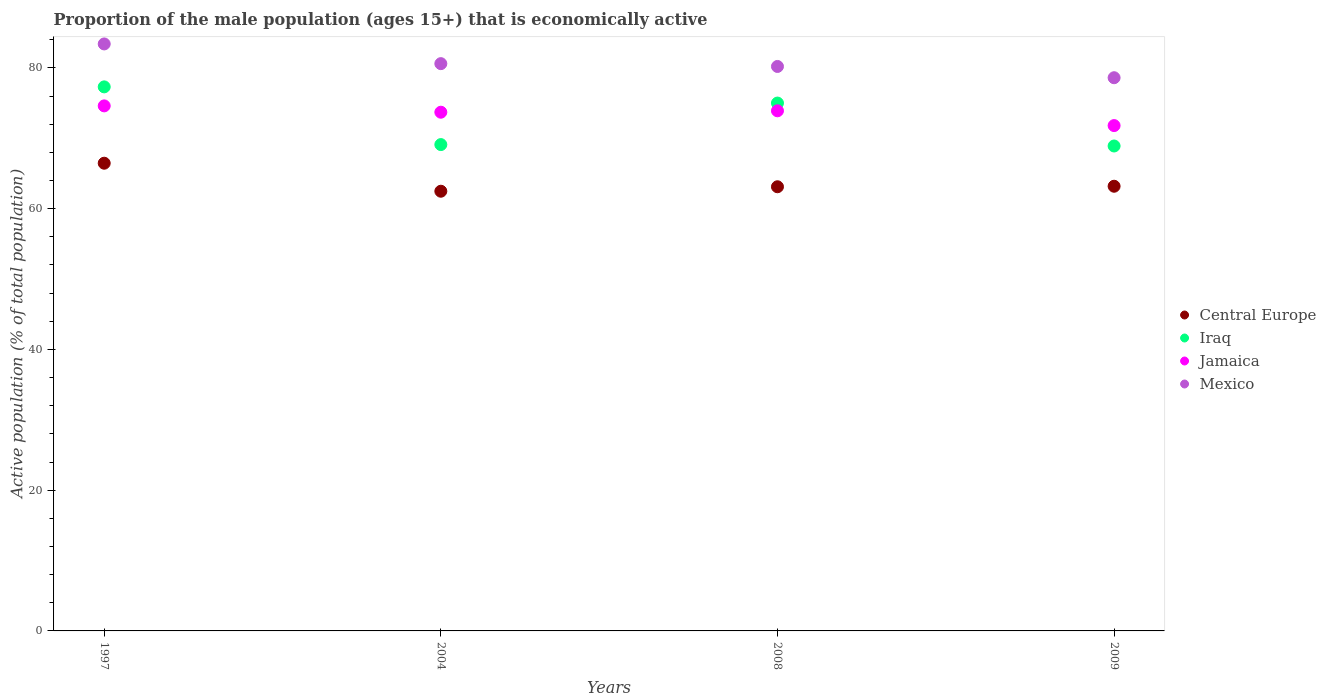What is the proportion of the male population that is economically active in Mexico in 2008?
Your answer should be very brief. 80.2. Across all years, what is the maximum proportion of the male population that is economically active in Central Europe?
Your response must be concise. 66.45. Across all years, what is the minimum proportion of the male population that is economically active in Jamaica?
Keep it short and to the point. 71.8. In which year was the proportion of the male population that is economically active in Mexico maximum?
Your answer should be compact. 1997. In which year was the proportion of the male population that is economically active in Jamaica minimum?
Offer a terse response. 2009. What is the total proportion of the male population that is economically active in Mexico in the graph?
Provide a succinct answer. 322.8. What is the difference between the proportion of the male population that is economically active in Central Europe in 1997 and that in 2008?
Give a very brief answer. 3.35. What is the difference between the proportion of the male population that is economically active in Jamaica in 2009 and the proportion of the male population that is economically active in Central Europe in 2008?
Provide a succinct answer. 8.69. What is the average proportion of the male population that is economically active in Central Europe per year?
Provide a short and direct response. 63.8. In how many years, is the proportion of the male population that is economically active in Central Europe greater than 44 %?
Provide a short and direct response. 4. What is the ratio of the proportion of the male population that is economically active in Mexico in 1997 to that in 2008?
Ensure brevity in your answer.  1.04. Is the proportion of the male population that is economically active in Mexico in 1997 less than that in 2004?
Make the answer very short. No. What is the difference between the highest and the second highest proportion of the male population that is economically active in Jamaica?
Provide a succinct answer. 0.7. What is the difference between the highest and the lowest proportion of the male population that is economically active in Iraq?
Provide a succinct answer. 8.4. In how many years, is the proportion of the male population that is economically active in Central Europe greater than the average proportion of the male population that is economically active in Central Europe taken over all years?
Ensure brevity in your answer.  1. Is the sum of the proportion of the male population that is economically active in Mexico in 1997 and 2004 greater than the maximum proportion of the male population that is economically active in Jamaica across all years?
Keep it short and to the point. Yes. Is it the case that in every year, the sum of the proportion of the male population that is economically active in Jamaica and proportion of the male population that is economically active in Mexico  is greater than the sum of proportion of the male population that is economically active in Iraq and proportion of the male population that is economically active in Central Europe?
Give a very brief answer. No. Is it the case that in every year, the sum of the proportion of the male population that is economically active in Jamaica and proportion of the male population that is economically active in Iraq  is greater than the proportion of the male population that is economically active in Central Europe?
Give a very brief answer. Yes. Does the proportion of the male population that is economically active in Central Europe monotonically increase over the years?
Your answer should be compact. No. Is the proportion of the male population that is economically active in Central Europe strictly greater than the proportion of the male population that is economically active in Iraq over the years?
Your answer should be very brief. No. Is the proportion of the male population that is economically active in Mexico strictly less than the proportion of the male population that is economically active in Central Europe over the years?
Offer a terse response. No. What is the difference between two consecutive major ticks on the Y-axis?
Offer a terse response. 20. Does the graph contain grids?
Offer a very short reply. No. What is the title of the graph?
Ensure brevity in your answer.  Proportion of the male population (ages 15+) that is economically active. What is the label or title of the X-axis?
Make the answer very short. Years. What is the label or title of the Y-axis?
Keep it short and to the point. Active population (% of total population). What is the Active population (% of total population) in Central Europe in 1997?
Ensure brevity in your answer.  66.45. What is the Active population (% of total population) in Iraq in 1997?
Give a very brief answer. 77.3. What is the Active population (% of total population) of Jamaica in 1997?
Offer a very short reply. 74.6. What is the Active population (% of total population) of Mexico in 1997?
Give a very brief answer. 83.4. What is the Active population (% of total population) of Central Europe in 2004?
Offer a terse response. 62.47. What is the Active population (% of total population) of Iraq in 2004?
Your response must be concise. 69.1. What is the Active population (% of total population) in Jamaica in 2004?
Offer a very short reply. 73.7. What is the Active population (% of total population) of Mexico in 2004?
Keep it short and to the point. 80.6. What is the Active population (% of total population) in Central Europe in 2008?
Your response must be concise. 63.11. What is the Active population (% of total population) of Jamaica in 2008?
Ensure brevity in your answer.  73.9. What is the Active population (% of total population) of Mexico in 2008?
Give a very brief answer. 80.2. What is the Active population (% of total population) of Central Europe in 2009?
Offer a terse response. 63.18. What is the Active population (% of total population) of Iraq in 2009?
Your answer should be very brief. 68.9. What is the Active population (% of total population) of Jamaica in 2009?
Your answer should be very brief. 71.8. What is the Active population (% of total population) in Mexico in 2009?
Your answer should be very brief. 78.6. Across all years, what is the maximum Active population (% of total population) in Central Europe?
Ensure brevity in your answer.  66.45. Across all years, what is the maximum Active population (% of total population) of Iraq?
Your response must be concise. 77.3. Across all years, what is the maximum Active population (% of total population) in Jamaica?
Provide a succinct answer. 74.6. Across all years, what is the maximum Active population (% of total population) in Mexico?
Keep it short and to the point. 83.4. Across all years, what is the minimum Active population (% of total population) of Central Europe?
Your response must be concise. 62.47. Across all years, what is the minimum Active population (% of total population) of Iraq?
Ensure brevity in your answer.  68.9. Across all years, what is the minimum Active population (% of total population) in Jamaica?
Offer a terse response. 71.8. Across all years, what is the minimum Active population (% of total population) of Mexico?
Provide a short and direct response. 78.6. What is the total Active population (% of total population) in Central Europe in the graph?
Your answer should be compact. 255.21. What is the total Active population (% of total population) of Iraq in the graph?
Provide a succinct answer. 290.3. What is the total Active population (% of total population) in Jamaica in the graph?
Ensure brevity in your answer.  294. What is the total Active population (% of total population) of Mexico in the graph?
Offer a very short reply. 322.8. What is the difference between the Active population (% of total population) of Central Europe in 1997 and that in 2004?
Provide a succinct answer. 3.98. What is the difference between the Active population (% of total population) of Iraq in 1997 and that in 2004?
Offer a terse response. 8.2. What is the difference between the Active population (% of total population) in Mexico in 1997 and that in 2004?
Provide a short and direct response. 2.8. What is the difference between the Active population (% of total population) of Central Europe in 1997 and that in 2008?
Provide a succinct answer. 3.35. What is the difference between the Active population (% of total population) of Central Europe in 1997 and that in 2009?
Ensure brevity in your answer.  3.27. What is the difference between the Active population (% of total population) of Iraq in 1997 and that in 2009?
Give a very brief answer. 8.4. What is the difference between the Active population (% of total population) in Jamaica in 1997 and that in 2009?
Offer a very short reply. 2.8. What is the difference between the Active population (% of total population) of Mexico in 1997 and that in 2009?
Your response must be concise. 4.8. What is the difference between the Active population (% of total population) of Central Europe in 2004 and that in 2008?
Make the answer very short. -0.64. What is the difference between the Active population (% of total population) of Iraq in 2004 and that in 2008?
Your answer should be compact. -5.9. What is the difference between the Active population (% of total population) of Jamaica in 2004 and that in 2008?
Offer a very short reply. -0.2. What is the difference between the Active population (% of total population) of Mexico in 2004 and that in 2008?
Ensure brevity in your answer.  0.4. What is the difference between the Active population (% of total population) of Central Europe in 2004 and that in 2009?
Ensure brevity in your answer.  -0.71. What is the difference between the Active population (% of total population) in Iraq in 2004 and that in 2009?
Your answer should be compact. 0.2. What is the difference between the Active population (% of total population) in Mexico in 2004 and that in 2009?
Offer a very short reply. 2. What is the difference between the Active population (% of total population) in Central Europe in 2008 and that in 2009?
Your answer should be very brief. -0.07. What is the difference between the Active population (% of total population) in Iraq in 2008 and that in 2009?
Give a very brief answer. 6.1. What is the difference between the Active population (% of total population) in Jamaica in 2008 and that in 2009?
Keep it short and to the point. 2.1. What is the difference between the Active population (% of total population) in Mexico in 2008 and that in 2009?
Make the answer very short. 1.6. What is the difference between the Active population (% of total population) of Central Europe in 1997 and the Active population (% of total population) of Iraq in 2004?
Give a very brief answer. -2.65. What is the difference between the Active population (% of total population) of Central Europe in 1997 and the Active population (% of total population) of Jamaica in 2004?
Your response must be concise. -7.25. What is the difference between the Active population (% of total population) in Central Europe in 1997 and the Active population (% of total population) in Mexico in 2004?
Provide a succinct answer. -14.15. What is the difference between the Active population (% of total population) in Iraq in 1997 and the Active population (% of total population) in Jamaica in 2004?
Provide a succinct answer. 3.6. What is the difference between the Active population (% of total population) of Iraq in 1997 and the Active population (% of total population) of Mexico in 2004?
Provide a short and direct response. -3.3. What is the difference between the Active population (% of total population) of Central Europe in 1997 and the Active population (% of total population) of Iraq in 2008?
Provide a short and direct response. -8.55. What is the difference between the Active population (% of total population) in Central Europe in 1997 and the Active population (% of total population) in Jamaica in 2008?
Provide a short and direct response. -7.45. What is the difference between the Active population (% of total population) in Central Europe in 1997 and the Active population (% of total population) in Mexico in 2008?
Keep it short and to the point. -13.75. What is the difference between the Active population (% of total population) of Central Europe in 1997 and the Active population (% of total population) of Iraq in 2009?
Your response must be concise. -2.45. What is the difference between the Active population (% of total population) in Central Europe in 1997 and the Active population (% of total population) in Jamaica in 2009?
Your answer should be compact. -5.35. What is the difference between the Active population (% of total population) in Central Europe in 1997 and the Active population (% of total population) in Mexico in 2009?
Your response must be concise. -12.15. What is the difference between the Active population (% of total population) in Iraq in 1997 and the Active population (% of total population) in Jamaica in 2009?
Offer a terse response. 5.5. What is the difference between the Active population (% of total population) of Iraq in 1997 and the Active population (% of total population) of Mexico in 2009?
Your answer should be very brief. -1.3. What is the difference between the Active population (% of total population) of Central Europe in 2004 and the Active population (% of total population) of Iraq in 2008?
Make the answer very short. -12.53. What is the difference between the Active population (% of total population) in Central Europe in 2004 and the Active population (% of total population) in Jamaica in 2008?
Make the answer very short. -11.43. What is the difference between the Active population (% of total population) in Central Europe in 2004 and the Active population (% of total population) in Mexico in 2008?
Your answer should be compact. -17.73. What is the difference between the Active population (% of total population) of Iraq in 2004 and the Active population (% of total population) of Mexico in 2008?
Offer a very short reply. -11.1. What is the difference between the Active population (% of total population) of Central Europe in 2004 and the Active population (% of total population) of Iraq in 2009?
Keep it short and to the point. -6.43. What is the difference between the Active population (% of total population) of Central Europe in 2004 and the Active population (% of total population) of Jamaica in 2009?
Offer a terse response. -9.33. What is the difference between the Active population (% of total population) of Central Europe in 2004 and the Active population (% of total population) of Mexico in 2009?
Provide a short and direct response. -16.13. What is the difference between the Active population (% of total population) of Central Europe in 2008 and the Active population (% of total population) of Iraq in 2009?
Offer a very short reply. -5.79. What is the difference between the Active population (% of total population) of Central Europe in 2008 and the Active population (% of total population) of Jamaica in 2009?
Your answer should be very brief. -8.69. What is the difference between the Active population (% of total population) of Central Europe in 2008 and the Active population (% of total population) of Mexico in 2009?
Ensure brevity in your answer.  -15.49. What is the difference between the Active population (% of total population) in Iraq in 2008 and the Active population (% of total population) in Jamaica in 2009?
Ensure brevity in your answer.  3.2. What is the average Active population (% of total population) of Central Europe per year?
Keep it short and to the point. 63.8. What is the average Active population (% of total population) of Iraq per year?
Give a very brief answer. 72.58. What is the average Active population (% of total population) of Jamaica per year?
Your answer should be compact. 73.5. What is the average Active population (% of total population) of Mexico per year?
Provide a short and direct response. 80.7. In the year 1997, what is the difference between the Active population (% of total population) of Central Europe and Active population (% of total population) of Iraq?
Give a very brief answer. -10.85. In the year 1997, what is the difference between the Active population (% of total population) of Central Europe and Active population (% of total population) of Jamaica?
Your answer should be compact. -8.15. In the year 1997, what is the difference between the Active population (% of total population) of Central Europe and Active population (% of total population) of Mexico?
Provide a succinct answer. -16.95. In the year 1997, what is the difference between the Active population (% of total population) of Jamaica and Active population (% of total population) of Mexico?
Your answer should be compact. -8.8. In the year 2004, what is the difference between the Active population (% of total population) of Central Europe and Active population (% of total population) of Iraq?
Make the answer very short. -6.63. In the year 2004, what is the difference between the Active population (% of total population) in Central Europe and Active population (% of total population) in Jamaica?
Make the answer very short. -11.23. In the year 2004, what is the difference between the Active population (% of total population) in Central Europe and Active population (% of total population) in Mexico?
Give a very brief answer. -18.13. In the year 2004, what is the difference between the Active population (% of total population) of Iraq and Active population (% of total population) of Mexico?
Offer a terse response. -11.5. In the year 2004, what is the difference between the Active population (% of total population) of Jamaica and Active population (% of total population) of Mexico?
Offer a very short reply. -6.9. In the year 2008, what is the difference between the Active population (% of total population) of Central Europe and Active population (% of total population) of Iraq?
Your response must be concise. -11.89. In the year 2008, what is the difference between the Active population (% of total population) in Central Europe and Active population (% of total population) in Jamaica?
Your response must be concise. -10.79. In the year 2008, what is the difference between the Active population (% of total population) in Central Europe and Active population (% of total population) in Mexico?
Your response must be concise. -17.09. In the year 2008, what is the difference between the Active population (% of total population) of Iraq and Active population (% of total population) of Mexico?
Keep it short and to the point. -5.2. In the year 2008, what is the difference between the Active population (% of total population) of Jamaica and Active population (% of total population) of Mexico?
Your response must be concise. -6.3. In the year 2009, what is the difference between the Active population (% of total population) in Central Europe and Active population (% of total population) in Iraq?
Ensure brevity in your answer.  -5.72. In the year 2009, what is the difference between the Active population (% of total population) in Central Europe and Active population (% of total population) in Jamaica?
Offer a very short reply. -8.62. In the year 2009, what is the difference between the Active population (% of total population) in Central Europe and Active population (% of total population) in Mexico?
Give a very brief answer. -15.42. What is the ratio of the Active population (% of total population) in Central Europe in 1997 to that in 2004?
Make the answer very short. 1.06. What is the ratio of the Active population (% of total population) of Iraq in 1997 to that in 2004?
Your answer should be compact. 1.12. What is the ratio of the Active population (% of total population) in Jamaica in 1997 to that in 2004?
Ensure brevity in your answer.  1.01. What is the ratio of the Active population (% of total population) of Mexico in 1997 to that in 2004?
Keep it short and to the point. 1.03. What is the ratio of the Active population (% of total population) in Central Europe in 1997 to that in 2008?
Your answer should be very brief. 1.05. What is the ratio of the Active population (% of total population) of Iraq in 1997 to that in 2008?
Your answer should be compact. 1.03. What is the ratio of the Active population (% of total population) of Jamaica in 1997 to that in 2008?
Keep it short and to the point. 1.01. What is the ratio of the Active population (% of total population) of Mexico in 1997 to that in 2008?
Give a very brief answer. 1.04. What is the ratio of the Active population (% of total population) of Central Europe in 1997 to that in 2009?
Your answer should be very brief. 1.05. What is the ratio of the Active population (% of total population) of Iraq in 1997 to that in 2009?
Offer a very short reply. 1.12. What is the ratio of the Active population (% of total population) of Jamaica in 1997 to that in 2009?
Give a very brief answer. 1.04. What is the ratio of the Active population (% of total population) in Mexico in 1997 to that in 2009?
Give a very brief answer. 1.06. What is the ratio of the Active population (% of total population) in Central Europe in 2004 to that in 2008?
Your answer should be very brief. 0.99. What is the ratio of the Active population (% of total population) in Iraq in 2004 to that in 2008?
Keep it short and to the point. 0.92. What is the ratio of the Active population (% of total population) in Jamaica in 2004 to that in 2008?
Your answer should be very brief. 1. What is the ratio of the Active population (% of total population) of Central Europe in 2004 to that in 2009?
Your response must be concise. 0.99. What is the ratio of the Active population (% of total population) of Jamaica in 2004 to that in 2009?
Ensure brevity in your answer.  1.03. What is the ratio of the Active population (% of total population) of Mexico in 2004 to that in 2009?
Ensure brevity in your answer.  1.03. What is the ratio of the Active population (% of total population) in Central Europe in 2008 to that in 2009?
Provide a short and direct response. 1. What is the ratio of the Active population (% of total population) in Iraq in 2008 to that in 2009?
Your answer should be very brief. 1.09. What is the ratio of the Active population (% of total population) of Jamaica in 2008 to that in 2009?
Provide a short and direct response. 1.03. What is the ratio of the Active population (% of total population) in Mexico in 2008 to that in 2009?
Make the answer very short. 1.02. What is the difference between the highest and the second highest Active population (% of total population) in Central Europe?
Offer a terse response. 3.27. What is the difference between the highest and the second highest Active population (% of total population) of Jamaica?
Offer a terse response. 0.7. What is the difference between the highest and the lowest Active population (% of total population) in Central Europe?
Give a very brief answer. 3.98. What is the difference between the highest and the lowest Active population (% of total population) in Iraq?
Provide a succinct answer. 8.4. What is the difference between the highest and the lowest Active population (% of total population) in Jamaica?
Your response must be concise. 2.8. 